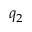Convert formula to latex. <formula><loc_0><loc_0><loc_500><loc_500>q _ { 2 }</formula> 